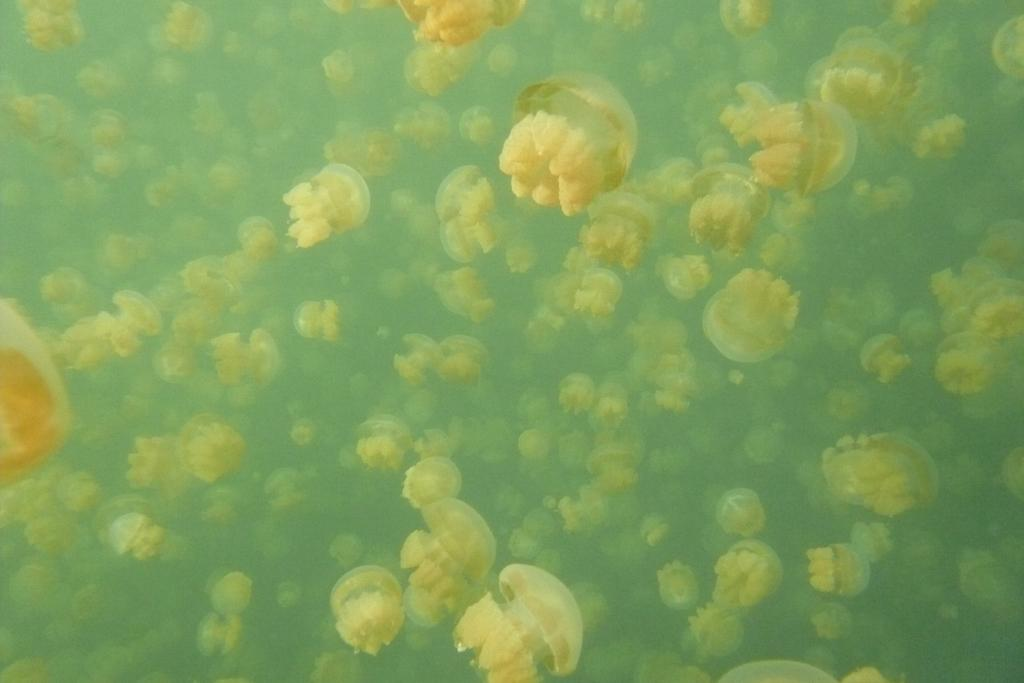What type of sea creatures are in the image? There are jellyfish in the image. Where are the jellyfish located? The jellyfish are in the water. How many bikes can be seen in the image? There are no bikes present in the image; it features jellyfish in the water. What type of legs are visible on the jellyfish in the image? Jellyfish do not have legs, so there are no legs visible on the jellyfish in the image. 